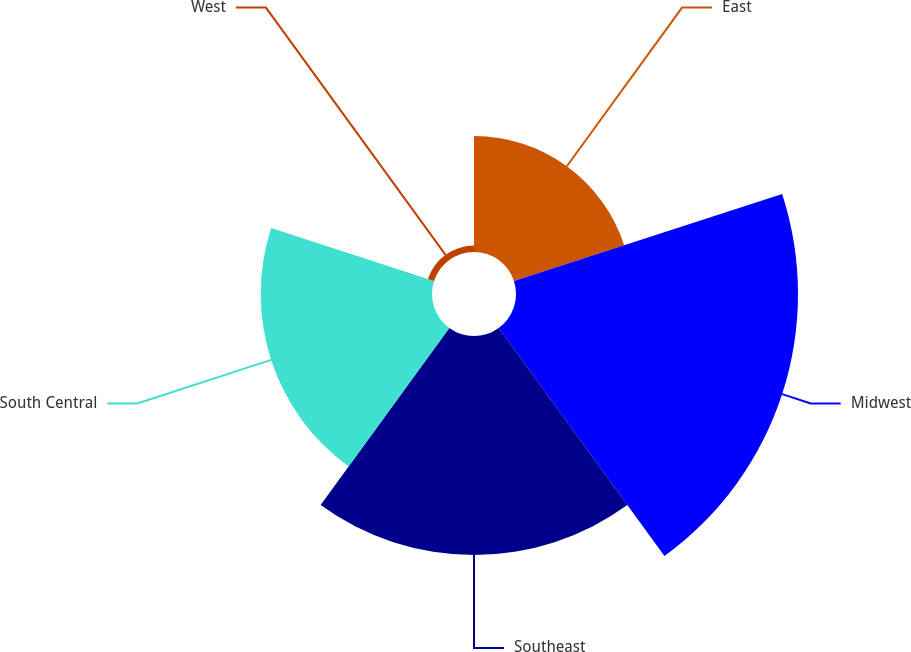Convert chart to OTSL. <chart><loc_0><loc_0><loc_500><loc_500><pie_chart><fcel>East<fcel>Midwest<fcel>Southeast<fcel>South Central<fcel>West<nl><fcel>14.59%<fcel>35.49%<fcel>27.55%<fcel>21.56%<fcel>0.81%<nl></chart> 